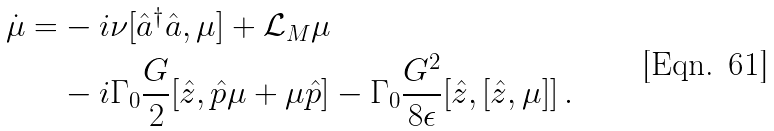<formula> <loc_0><loc_0><loc_500><loc_500>\dot { \mu } = & - i \nu [ \hat { a } ^ { \dag } \hat { a } , \mu ] + \mathcal { L } _ { M } \mu \\ & - i \Gamma _ { 0 } \frac { G } { 2 } [ \hat { z } , \hat { p } \mu + \mu \hat { p } ] - \Gamma _ { 0 } \frac { G ^ { 2 } } { 8 \epsilon } [ \hat { z } , [ \hat { z } , \mu ] ] \, .</formula> 